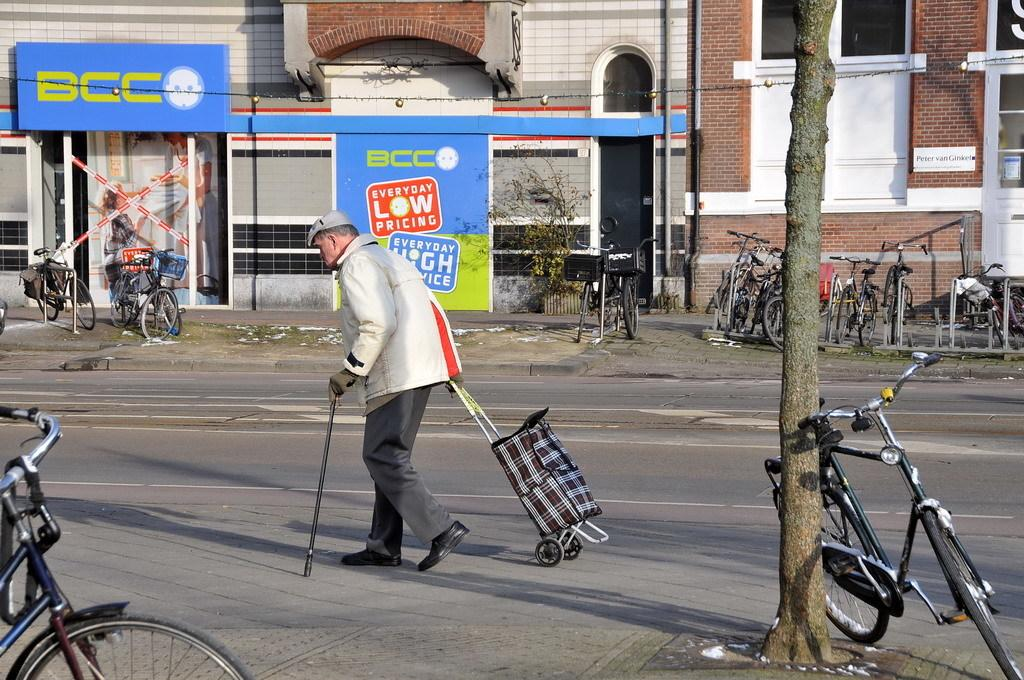What is the man in the image doing? The man is walking in the image. What is the man holding in addition to walking? The man is holding a walking stick and a trolley. What can be seen in the image besides the man? There are bicycles, buildings, and trees in the background of the image. What hobbies does the man enjoy, as seen in the image? The image does not provide information about the man's hobbies. What advice does the man give to the viewer, as seen in the image? The image does not show the man giving any advice to the viewer. 